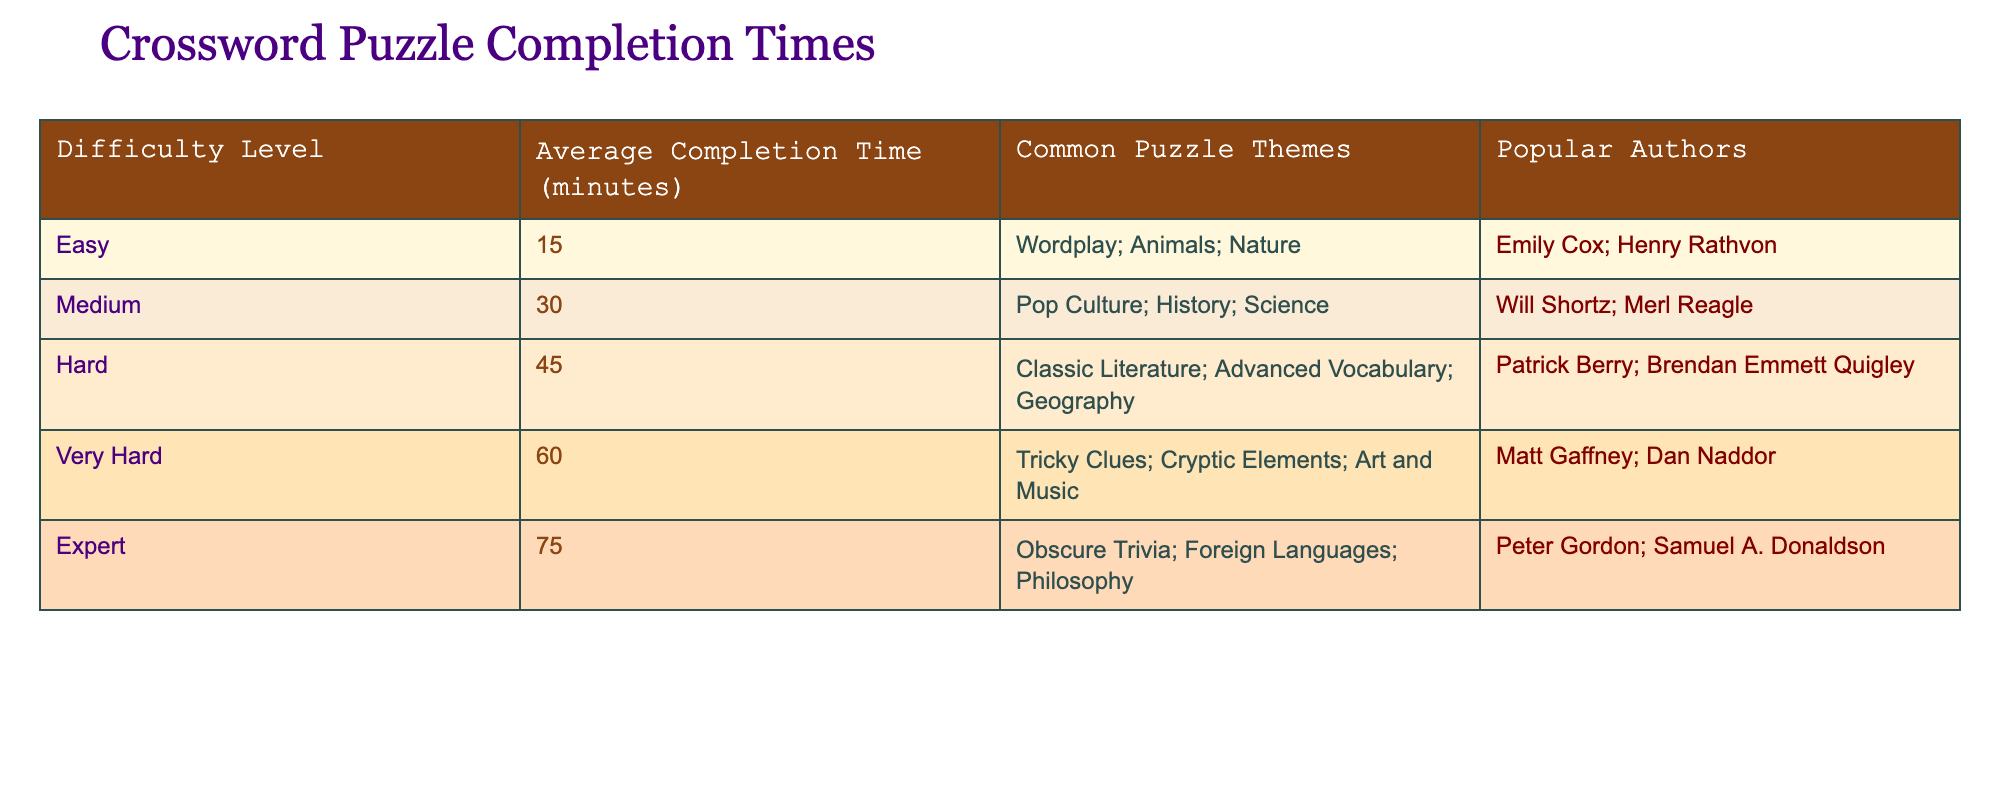What is the average completion time for Easy level puzzles? The table lists the average completion time for Easy level puzzles as 15 minutes.
Answer: 15 minutes Which difficulty level has the longest average completion time? The table shows that the Expert level has the longest average completion time at 75 minutes.
Answer: Expert Are there any common themes mentioned for the Hard level puzzles? The table indicates that the common themes for Hard level puzzles include Classic Literature, Advanced Vocabulary, and Geography.
Answer: Yes How much longer is the average completion time for Very Hard puzzles compared to Medium puzzles? The average completion time for Very Hard is 60 minutes, and for Medium it is 30 minutes. The difference is 60 - 30 = 30 minutes.
Answer: 30 minutes Which author is associated with the Easy difficulty level puzzles? According to the table, Emily Cox and Henry Rathvon are the authors associated with Easy level puzzles.
Answer: Emily Cox and Henry Rathvon If a puzzle takes 45 minutes to complete, which difficulty levels could it belong to? The table shows that 45 minutes is the average for Hard level puzzles, and Very Hard is 60 minutes. Therefore, a 45-minute puzzle could only belong to the Hard level.
Answer: Hard What is the average completion time for all difficulty levels combined? The average is calculated by summing completion times (15+30+45+60+75 = 225) and dividing by the number of levels (5), yielding an average of 225/5 = 45 minutes.
Answer: 45 minutes Is it true that Pop Culture is a common theme for Easy level puzzles? The table specifies that Pop Culture is listed under Medium level puzzles, not Easy. Hence, the statement is false.
Answer: No Identify the total average completion time for Easy and Medium levels. To find this, add the average times for Easy (15 minutes) and Medium (30 minutes) together: 15 + 30 = 45 minutes.
Answer: 45 minutes Which difficulty category features popular authors like Peter Gordon? Peter Gordon is listed under the Expert level in the table.
Answer: Expert What average completion time would you expect for someone attempting the hardest puzzles? The table indicates that the expected average completion time for Expert level puzzles, the hardest category, is 75 minutes.
Answer: 75 minutes 